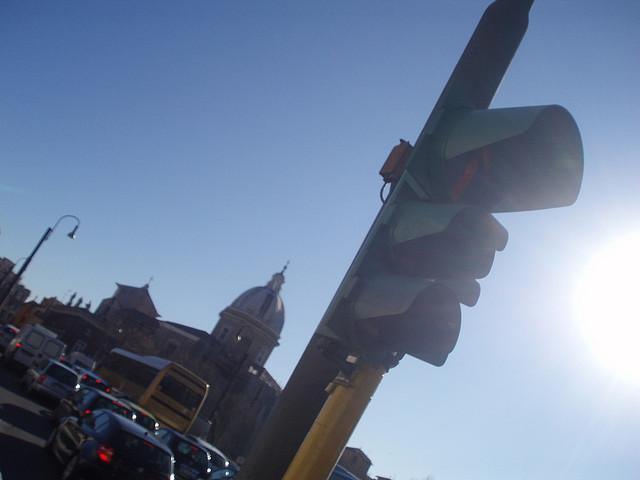How many clouds are in the sky?
Give a very brief answer. 0. 